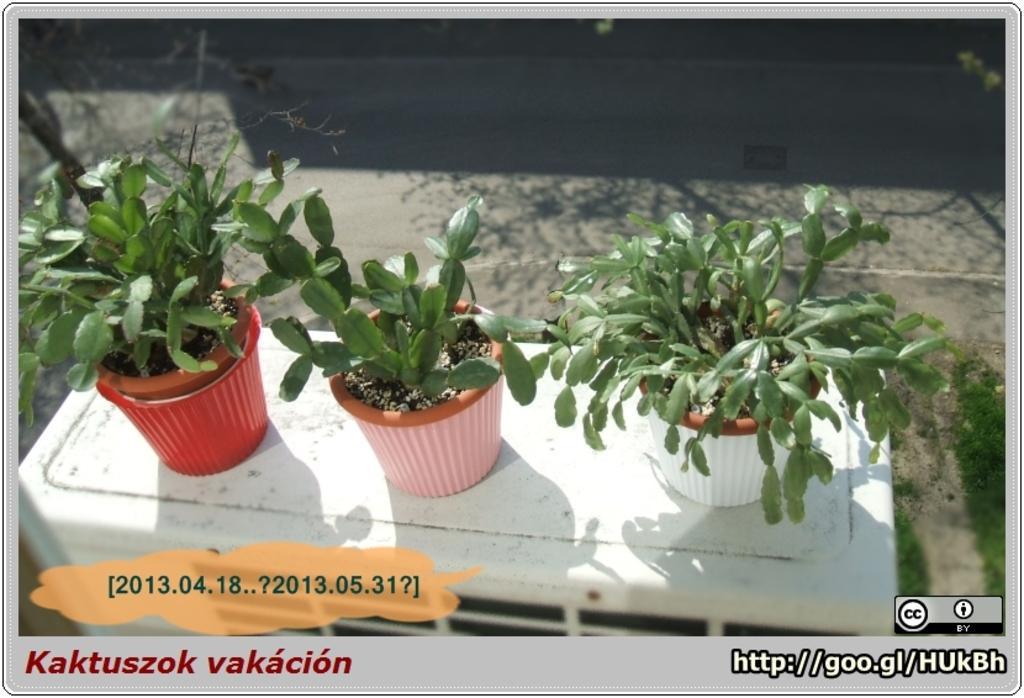What type of living organisms can be seen in the image? Plants can be seen in the image. Where are the plants located? The plants are in pots. What is the plants resting on? The plants are placed on a surface. What else can be seen in the image besides the plants? There is text visible in the image. What country is the grip of the finger from in the image? There is no finger or grip present in the image, as it only features plants in pots and text. 